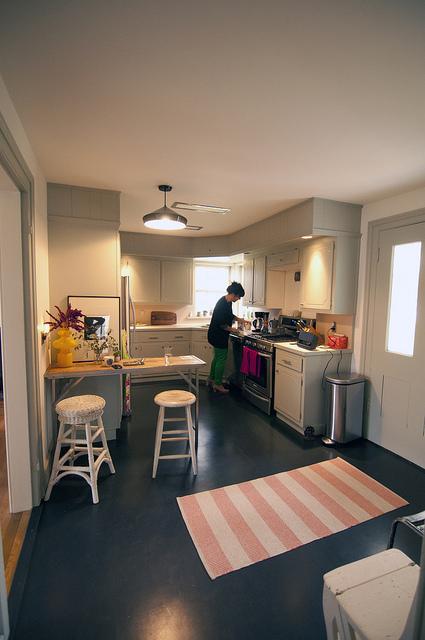How many white bar stools?
Short answer required. 2. Is there a light on?
Keep it brief. Yes. Is the person in the kitchen preparing food?
Concise answer only. Yes. What color is the carpet?
Be succinct. Pink and white. 